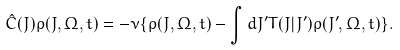Convert formula to latex. <formula><loc_0><loc_0><loc_500><loc_500>\hat { C } ( J ) \rho ( J , \Omega , t ) = - \nu \{ \rho ( J , \Omega , t ) - \int d J ^ { \prime } T ( J | J ^ { \prime } ) \rho ( J ^ { \prime } , \Omega , t ) \} .</formula> 